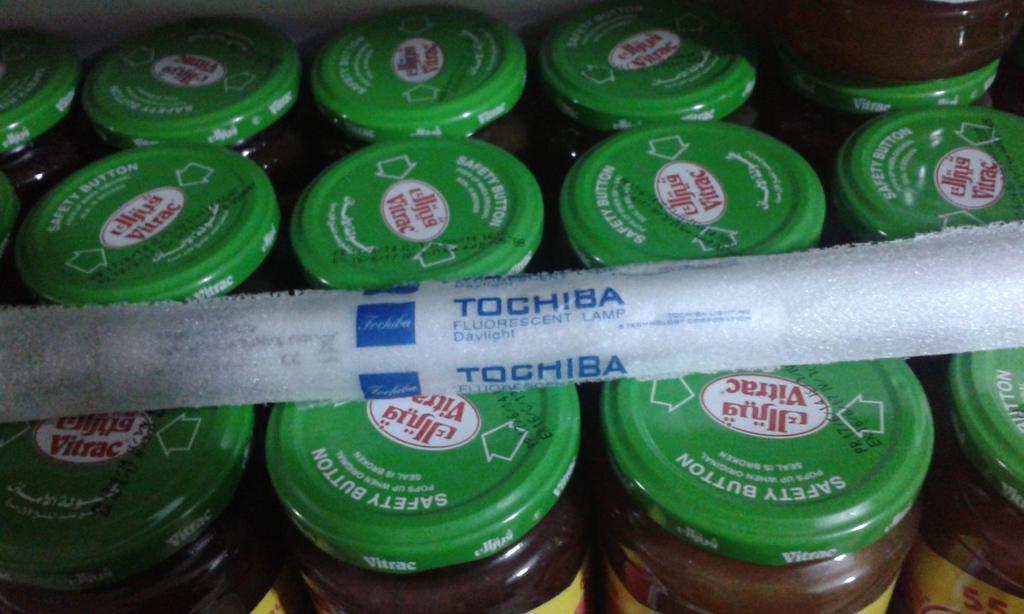Describe this image in one or two sentences. Here in this picture we can see number of glass jars with caps on it present over a place and at the top of it we can see a cloth present. 